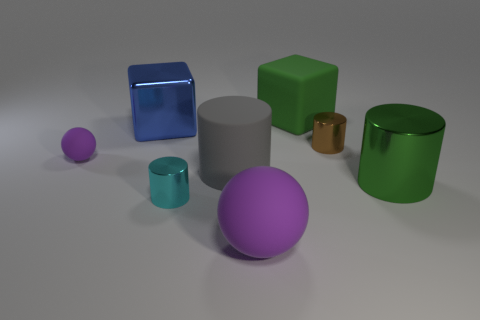The shiny cylinder that is the same color as the rubber block is what size?
Keep it short and to the point. Large. There is a object that is the same color as the large matte sphere; what is its shape?
Offer a very short reply. Sphere. What number of other objects are there of the same material as the large gray object?
Ensure brevity in your answer.  3. What is the color of the small cylinder that is in front of the matte sphere that is to the left of the cyan metal cylinder that is left of the brown shiny object?
Your answer should be compact. Cyan. What shape is the big metallic object that is behind the big metal object that is on the right side of the large shiny block?
Ensure brevity in your answer.  Cube. Are there more big rubber blocks behind the gray matte cylinder than big green shiny cubes?
Your answer should be compact. Yes. There is a big shiny thing that is left of the gray rubber cylinder; is its shape the same as the green matte thing?
Offer a very short reply. Yes. Is there a large matte object that has the same shape as the tiny purple object?
Provide a short and direct response. Yes. What number of objects are either green things to the right of the big green matte object or small blocks?
Provide a succinct answer. 1. Is the number of big rubber blocks greater than the number of purple rubber cylinders?
Your answer should be very brief. Yes. 